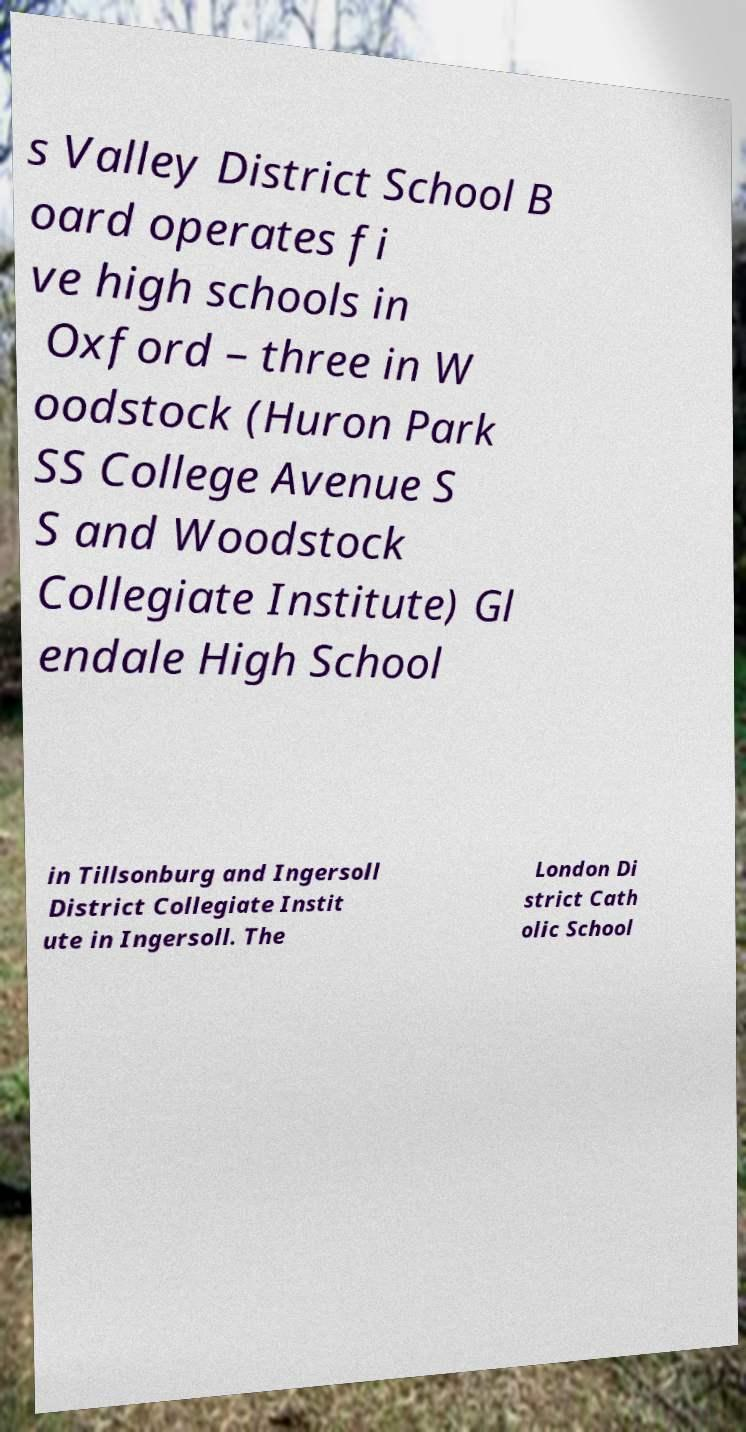I need the written content from this picture converted into text. Can you do that? s Valley District School B oard operates fi ve high schools in Oxford – three in W oodstock (Huron Park SS College Avenue S S and Woodstock Collegiate Institute) Gl endale High School in Tillsonburg and Ingersoll District Collegiate Instit ute in Ingersoll. The London Di strict Cath olic School 